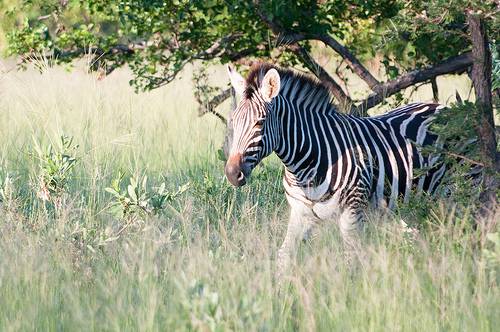Please provide the bounding box coordinate of the region this sentence describes: the leaves of a tree. The bounding box coordinates for the leaves of the tree are approximately [0.01, 0.17, 0.95, 0.32]. This region likely contains the main mass of foliage shown in the image. 